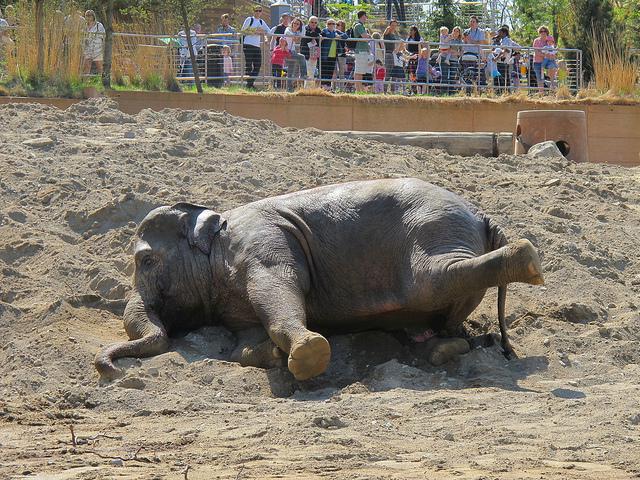Where are the people?
Keep it brief. Behind fence. What is the elephant laying in?
Give a very brief answer. Sand. What animal is seen?
Give a very brief answer. Elephant. 